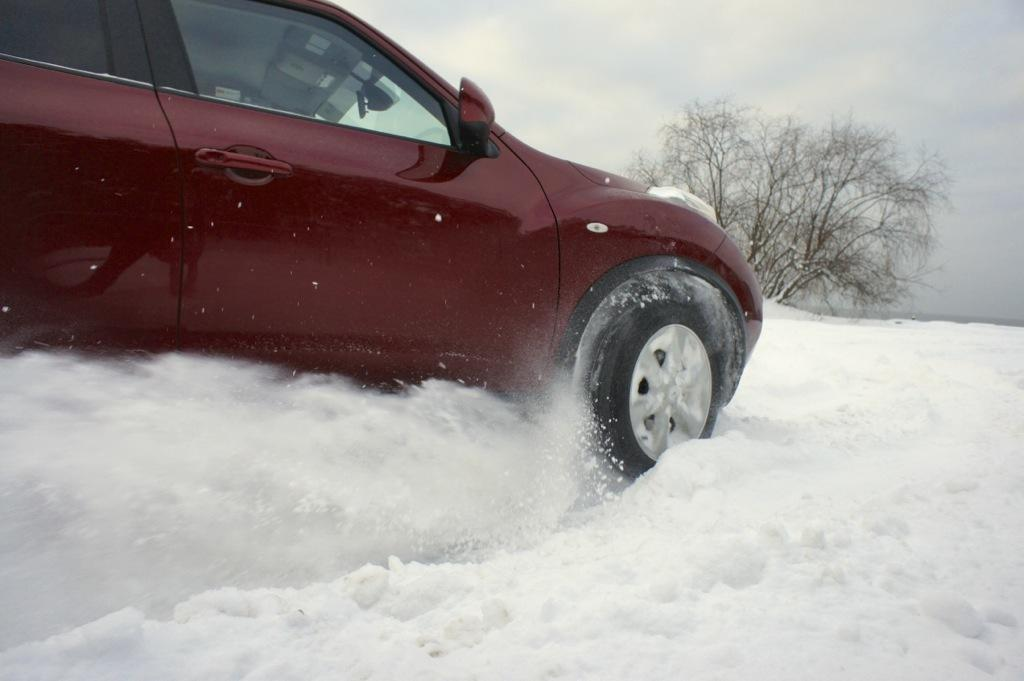What is the main subject of the image? The main subject of the image is a car. Where is the car located in the image? The car is on land covered with snow. What can be seen in the background of the image? There is a tree and the sky visible in the background of the image. What type of yarn is being used to decorate the stage in the image? There is no stage or yarn present in the image; it features a car on snow-covered land with a tree and sky in the background. 